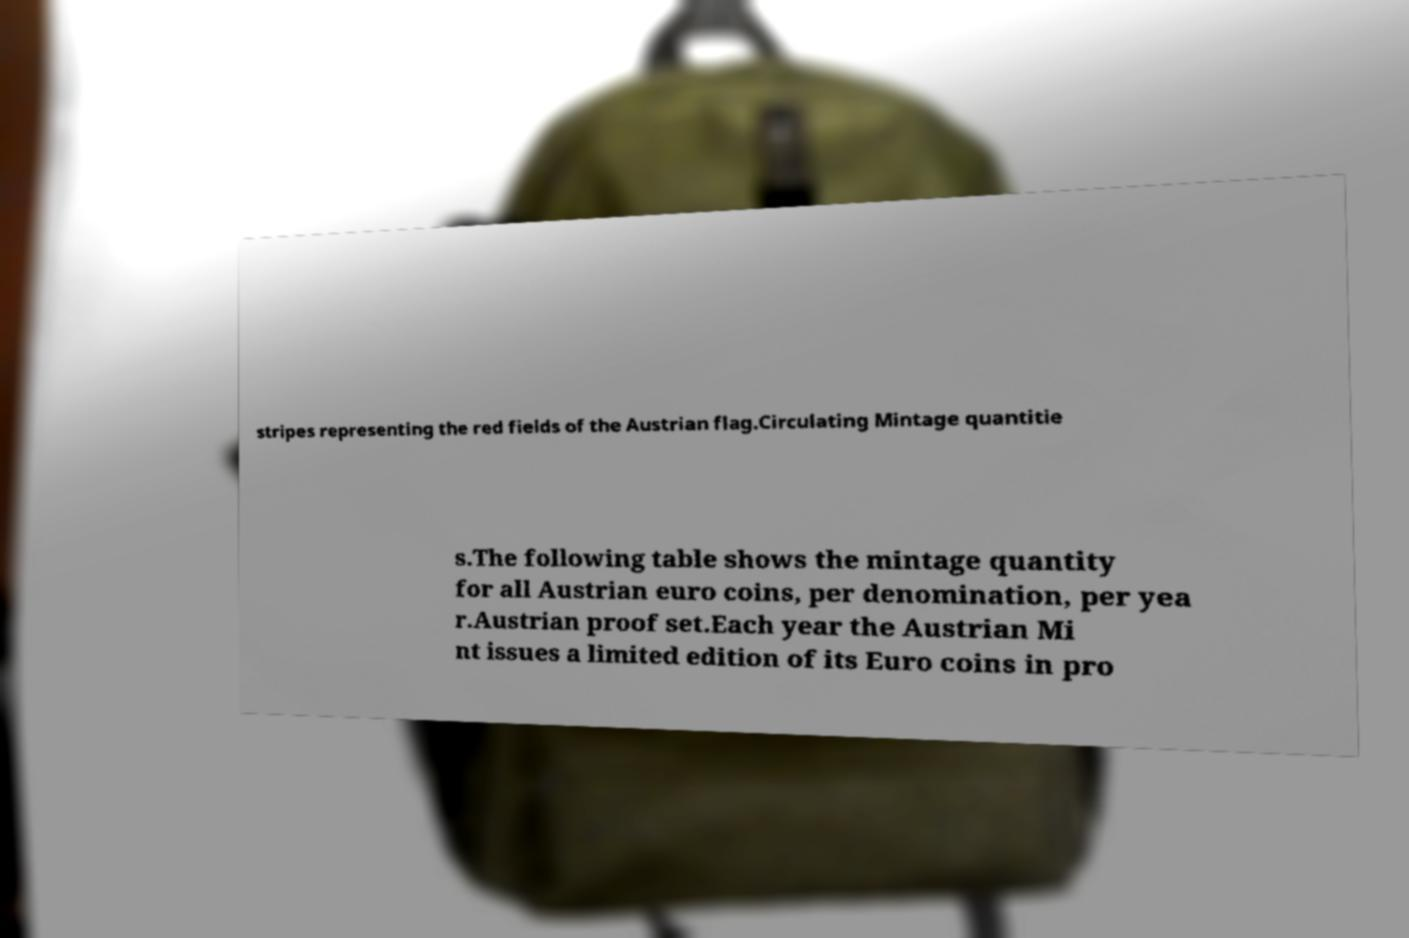Can you read and provide the text displayed in the image?This photo seems to have some interesting text. Can you extract and type it out for me? stripes representing the red fields of the Austrian flag.Circulating Mintage quantitie s.The following table shows the mintage quantity for all Austrian euro coins, per denomination, per yea r.Austrian proof set.Each year the Austrian Mi nt issues a limited edition of its Euro coins in pro 